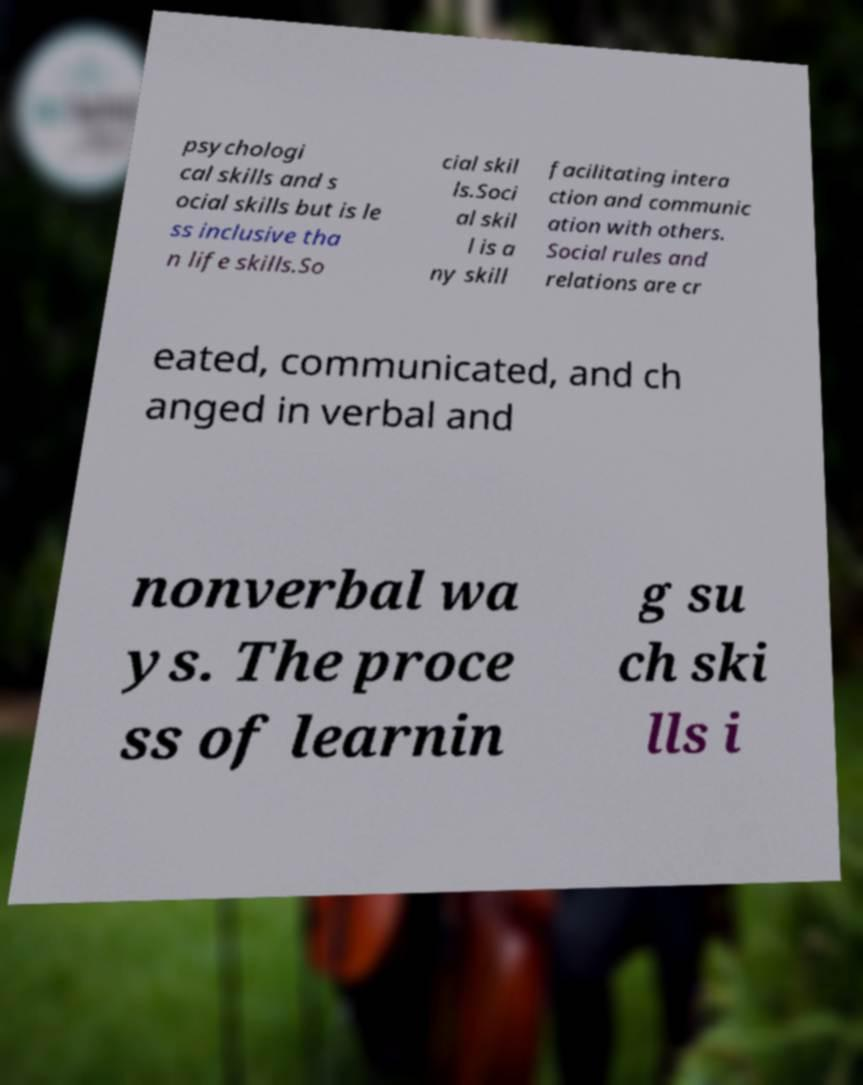Please read and relay the text visible in this image. What does it say? psychologi cal skills and s ocial skills but is le ss inclusive tha n life skills.So cial skil ls.Soci al skil l is a ny skill facilitating intera ction and communic ation with others. Social rules and relations are cr eated, communicated, and ch anged in verbal and nonverbal wa ys. The proce ss of learnin g su ch ski lls i 